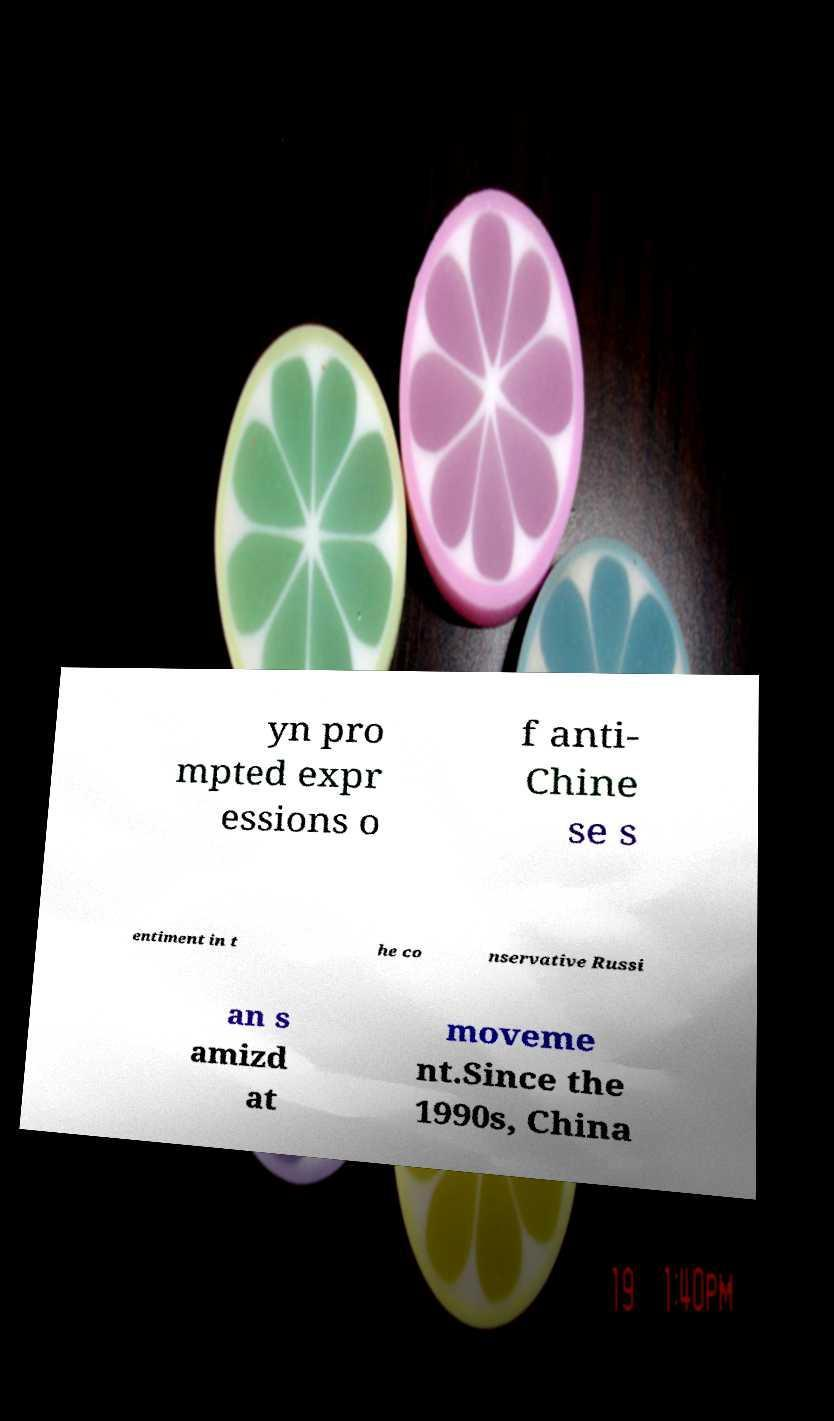Can you accurately transcribe the text from the provided image for me? yn pro mpted expr essions o f anti- Chine se s entiment in t he co nservative Russi an s amizd at moveme nt.Since the 1990s, China 